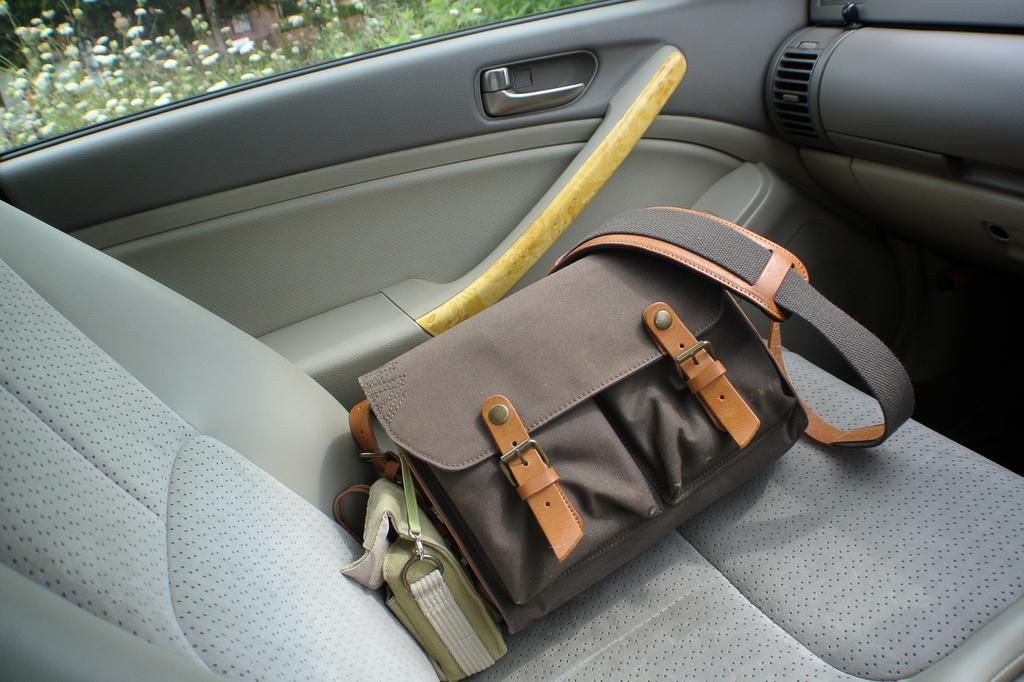In one or two sentences, can you explain what this image depicts? In this image I see the inside view of a car and there is a bag over here. I can also see few plants. 